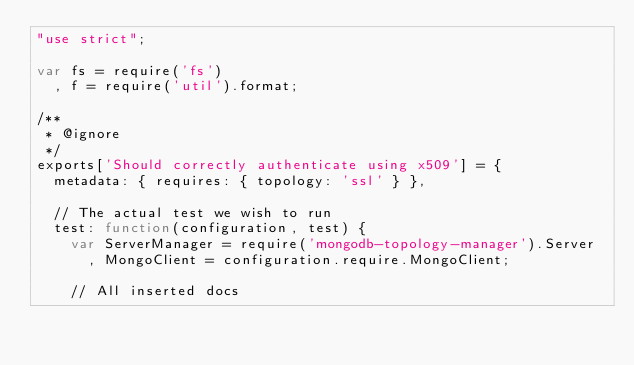<code> <loc_0><loc_0><loc_500><loc_500><_JavaScript_>"use strict";

var fs = require('fs')
  , f = require('util').format;

/**
 * @ignore
 */
exports['Should correctly authenticate using x509'] = {
  metadata: { requires: { topology: 'ssl' } },

  // The actual test we wish to run
  test: function(configuration, test) {
    var ServerManager = require('mongodb-topology-manager').Server
      , MongoClient = configuration.require.MongoClient;

    // All inserted docs</code> 